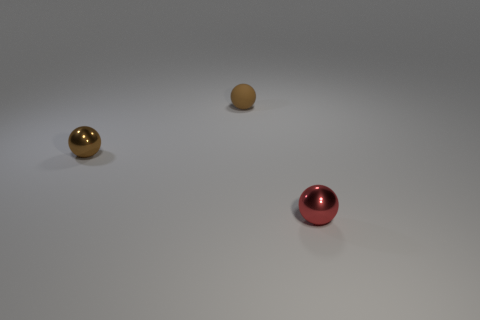The metallic object that is the same color as the matte ball is what shape?
Your answer should be very brief. Sphere. What number of yellow things are the same shape as the small red object?
Ensure brevity in your answer.  0. There is another metal thing that is the same size as the red thing; what is its color?
Your response must be concise. Brown. Are there any small red things?
Make the answer very short. Yes. What number of small objects are to the right of the brown shiny thing and in front of the matte sphere?
Your response must be concise. 1. Is there a large red cylinder made of the same material as the red object?
Give a very brief answer. No. There is a metal sphere that is the same color as the matte object; what is its size?
Make the answer very short. Small. What number of spheres are either small brown rubber things or tiny red objects?
Provide a short and direct response. 2. How big is the red metallic object?
Ensure brevity in your answer.  Small. There is a small brown shiny object; what number of tiny brown metal spheres are to the right of it?
Keep it short and to the point. 0. 